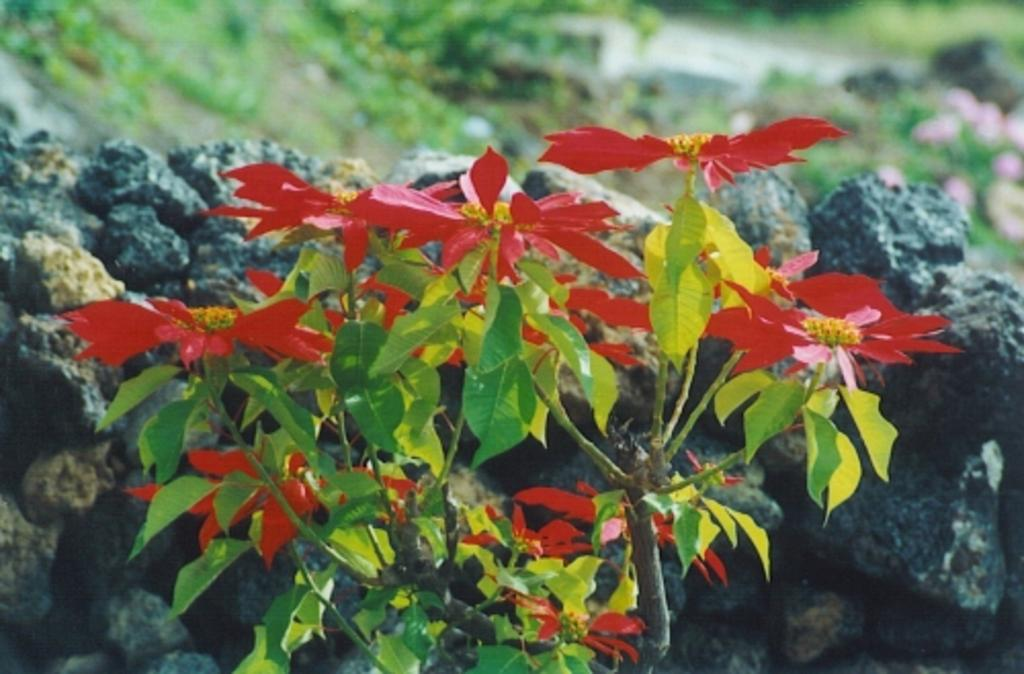What types of vegetation can be seen in the foreground of the image? There are flowers and plants in the foreground of the image. What types of objects can be seen in the background of the image? There are rocks, grass, plants, and flowers in the background of the image. Can you describe the vegetation in the background of the image? The background of the image features grass, plants, and flowers. How many cakes are balanced on the rocks in the image? There are no cakes present in the image, and the rocks are not depicted as balancing anything. 